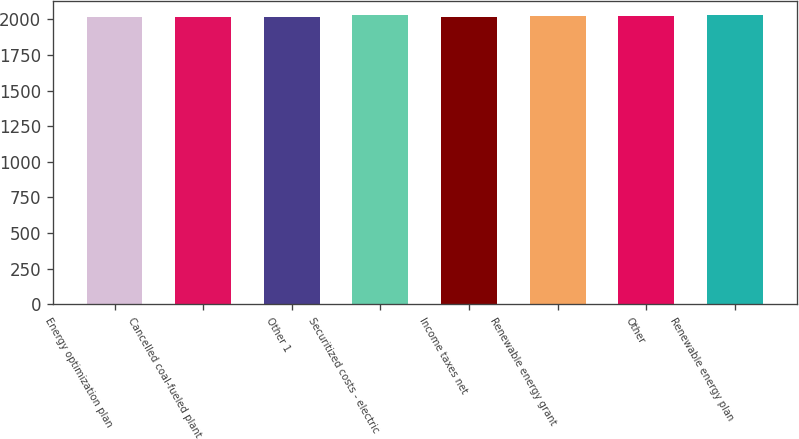Convert chart. <chart><loc_0><loc_0><loc_500><loc_500><bar_chart><fcel>Energy optimization plan<fcel>Cancelled coal-fueled plant<fcel>Other 1<fcel>Securitized costs - electric<fcel>Income taxes net<fcel>Renewable energy grant<fcel>Other<fcel>Renewable energy plan<nl><fcel>2015<fcel>2016.4<fcel>2017.8<fcel>2029.4<fcel>2019.2<fcel>2020.6<fcel>2022<fcel>2028<nl></chart> 